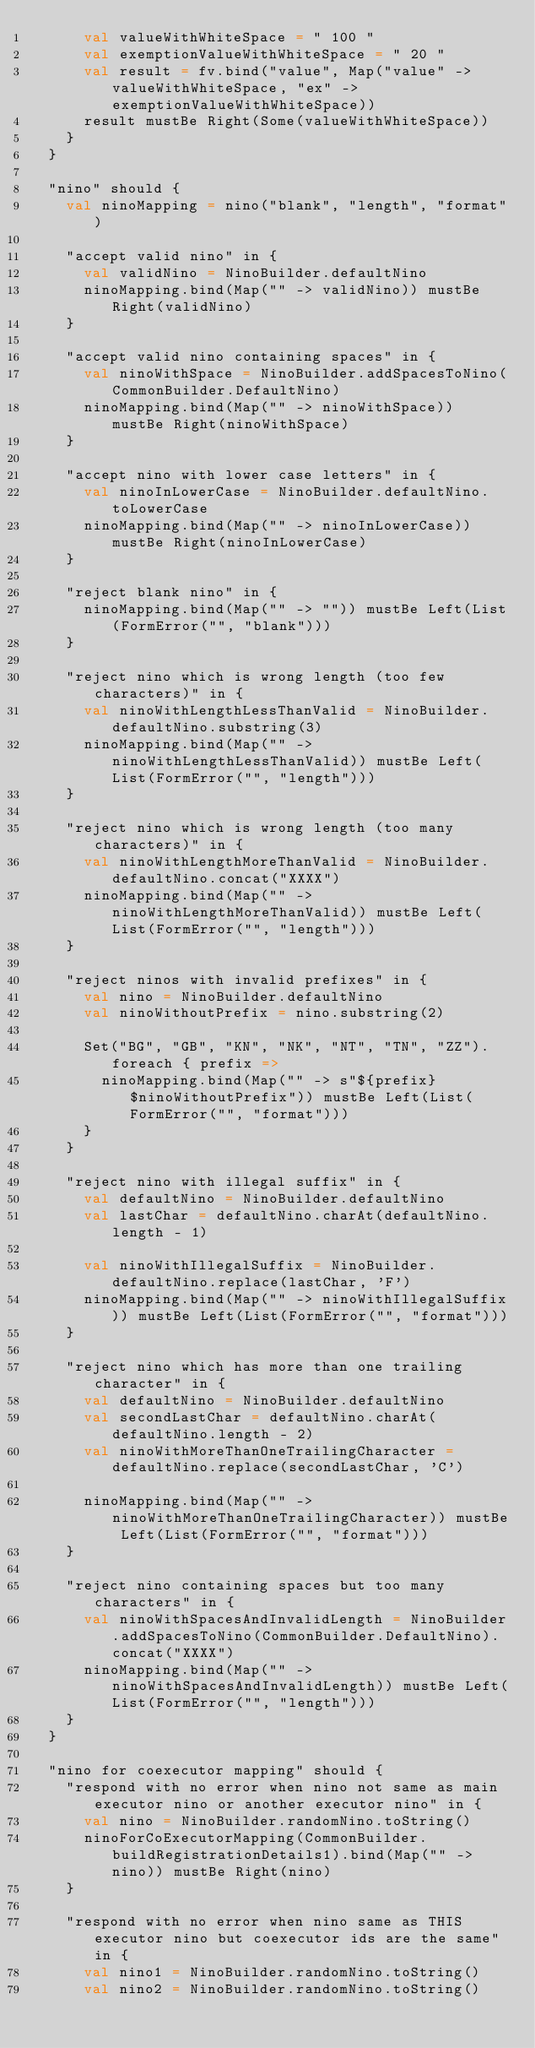<code> <loc_0><loc_0><loc_500><loc_500><_Scala_>      val valueWithWhiteSpace = " 100 "
      val exemptionValueWithWhiteSpace = " 20 "
      val result = fv.bind("value", Map("value" -> valueWithWhiteSpace, "ex" -> exemptionValueWithWhiteSpace))
      result mustBe Right(Some(valueWithWhiteSpace))
    }
  }

  "nino" should {
    val ninoMapping = nino("blank", "length", "format")

    "accept valid nino" in {
      val validNino = NinoBuilder.defaultNino
      ninoMapping.bind(Map("" -> validNino)) mustBe Right(validNino)
    }

    "accept valid nino containing spaces" in {
      val ninoWithSpace = NinoBuilder.addSpacesToNino(CommonBuilder.DefaultNino)
      ninoMapping.bind(Map("" -> ninoWithSpace)) mustBe Right(ninoWithSpace)
    }

    "accept nino with lower case letters" in {
      val ninoInLowerCase = NinoBuilder.defaultNino.toLowerCase
      ninoMapping.bind(Map("" -> ninoInLowerCase)) mustBe Right(ninoInLowerCase)
    }

    "reject blank nino" in {
      ninoMapping.bind(Map("" -> "")) mustBe Left(List(FormError("", "blank")))
    }

    "reject nino which is wrong length (too few characters)" in {
      val ninoWithLengthLessThanValid = NinoBuilder.defaultNino.substring(3)
      ninoMapping.bind(Map("" -> ninoWithLengthLessThanValid)) mustBe Left(List(FormError("", "length")))
    }

    "reject nino which is wrong length (too many characters)" in {
      val ninoWithLengthMoreThanValid = NinoBuilder.defaultNino.concat("XXXX")
      ninoMapping.bind(Map("" -> ninoWithLengthMoreThanValid)) mustBe Left(List(FormError("", "length")))
    }

    "reject ninos with invalid prefixes" in {
      val nino = NinoBuilder.defaultNino
      val ninoWithoutPrefix = nino.substring(2)

      Set("BG", "GB", "KN", "NK", "NT", "TN", "ZZ").foreach { prefix =>
        ninoMapping.bind(Map("" -> s"${prefix}$ninoWithoutPrefix")) mustBe Left(List(FormError("", "format")))
      }
    }

    "reject nino with illegal suffix" in {
      val defaultNino = NinoBuilder.defaultNino
      val lastChar = defaultNino.charAt(defaultNino.length - 1)

      val ninoWithIllegalSuffix = NinoBuilder.defaultNino.replace(lastChar, 'F')
      ninoMapping.bind(Map("" -> ninoWithIllegalSuffix)) mustBe Left(List(FormError("", "format")))
    }

    "reject nino which has more than one trailing character" in {
      val defaultNino = NinoBuilder.defaultNino
      val secondLastChar = defaultNino.charAt(defaultNino.length - 2)
      val ninoWithMoreThanOneTrailingCharacter = defaultNino.replace(secondLastChar, 'C')

      ninoMapping.bind(Map("" -> ninoWithMoreThanOneTrailingCharacter)) mustBe Left(List(FormError("", "format")))
    }

    "reject nino containing spaces but too many characters" in {
      val ninoWithSpacesAndInvalidLength = NinoBuilder.addSpacesToNino(CommonBuilder.DefaultNino).concat("XXXX")
      ninoMapping.bind(Map("" -> ninoWithSpacesAndInvalidLength)) mustBe Left(List(FormError("", "length")))
    }
  }

  "nino for coexecutor mapping" should {
    "respond with no error when nino not same as main executor nino or another executor nino" in {
      val nino = NinoBuilder.randomNino.toString()
      ninoForCoExecutorMapping(CommonBuilder.buildRegistrationDetails1).bind(Map("" -> nino)) mustBe Right(nino)
    }

    "respond with no error when nino same as THIS executor nino but coexecutor ids are the same" in {
      val nino1 = NinoBuilder.randomNino.toString()
      val nino2 = NinoBuilder.randomNino.toString()</code> 